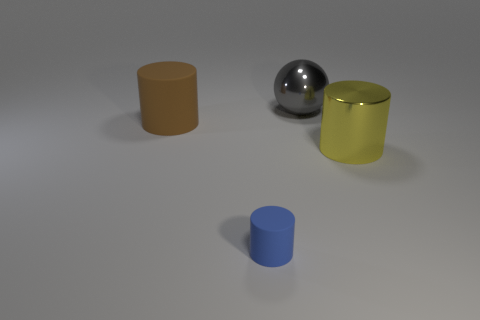Subtract all large cylinders. How many cylinders are left? 1 Add 1 big metal cubes. How many objects exist? 5 Subtract 3 cylinders. How many cylinders are left? 0 Subtract all balls. How many objects are left? 3 Subtract all brown blocks. How many brown cylinders are left? 1 Subtract all blue cylinders. How many cylinders are left? 2 Add 4 large spheres. How many large spheres exist? 5 Subtract 1 gray spheres. How many objects are left? 3 Subtract all green balls. Subtract all green blocks. How many balls are left? 1 Subtract all big green spheres. Subtract all matte cylinders. How many objects are left? 2 